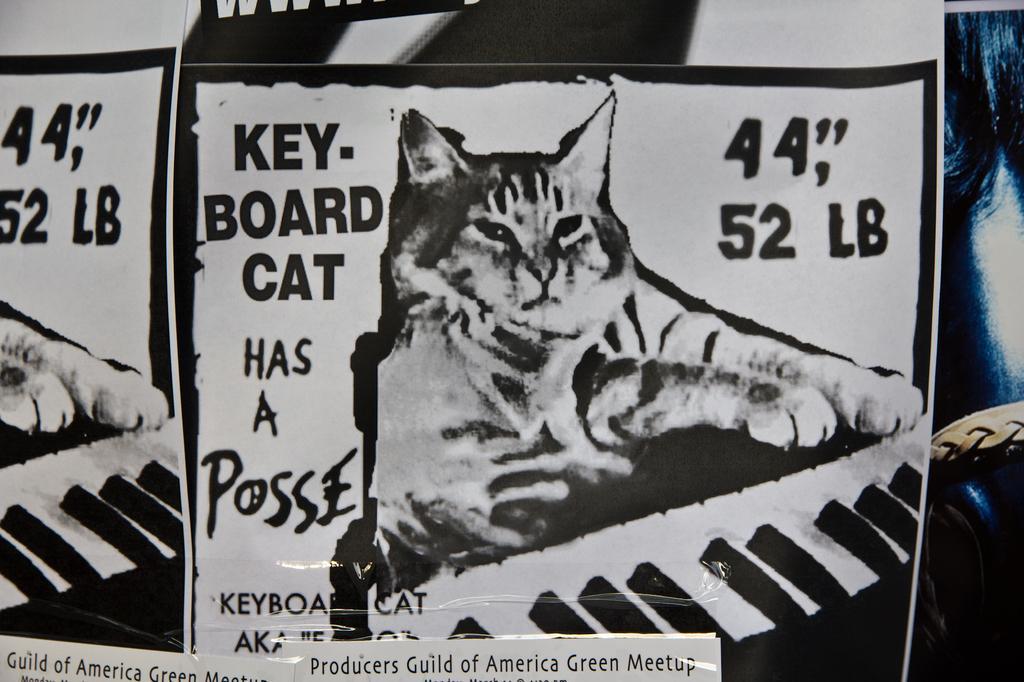How would you summarize this image in a sentence or two? In this picture we can see posters, papers, belt and on these posters we can see cats, keyboards and some text and in the background we can see some objects. 